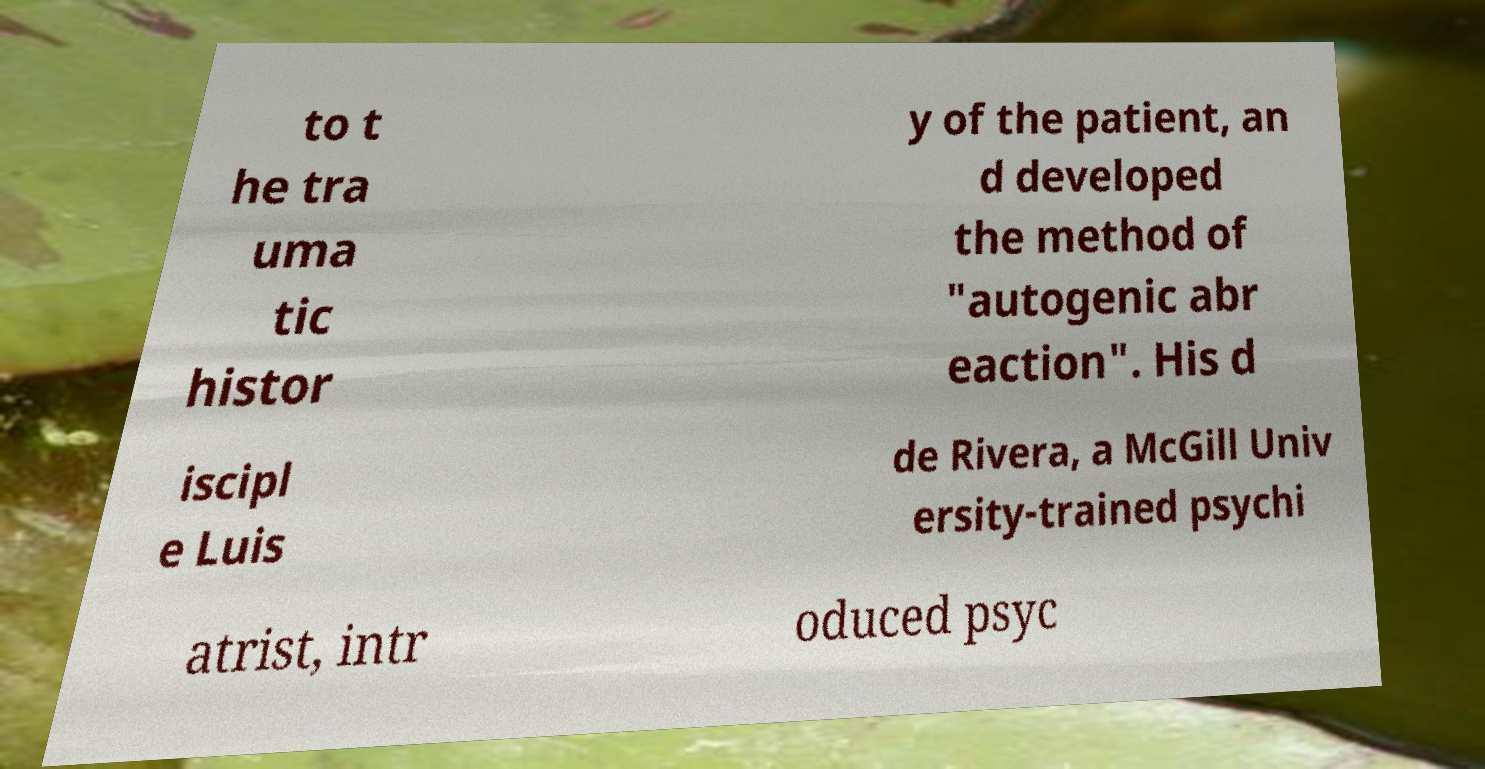Please identify and transcribe the text found in this image. to t he tra uma tic histor y of the patient, an d developed the method of "autogenic abr eaction". His d iscipl e Luis de Rivera, a McGill Univ ersity-trained psychi atrist, intr oduced psyc 